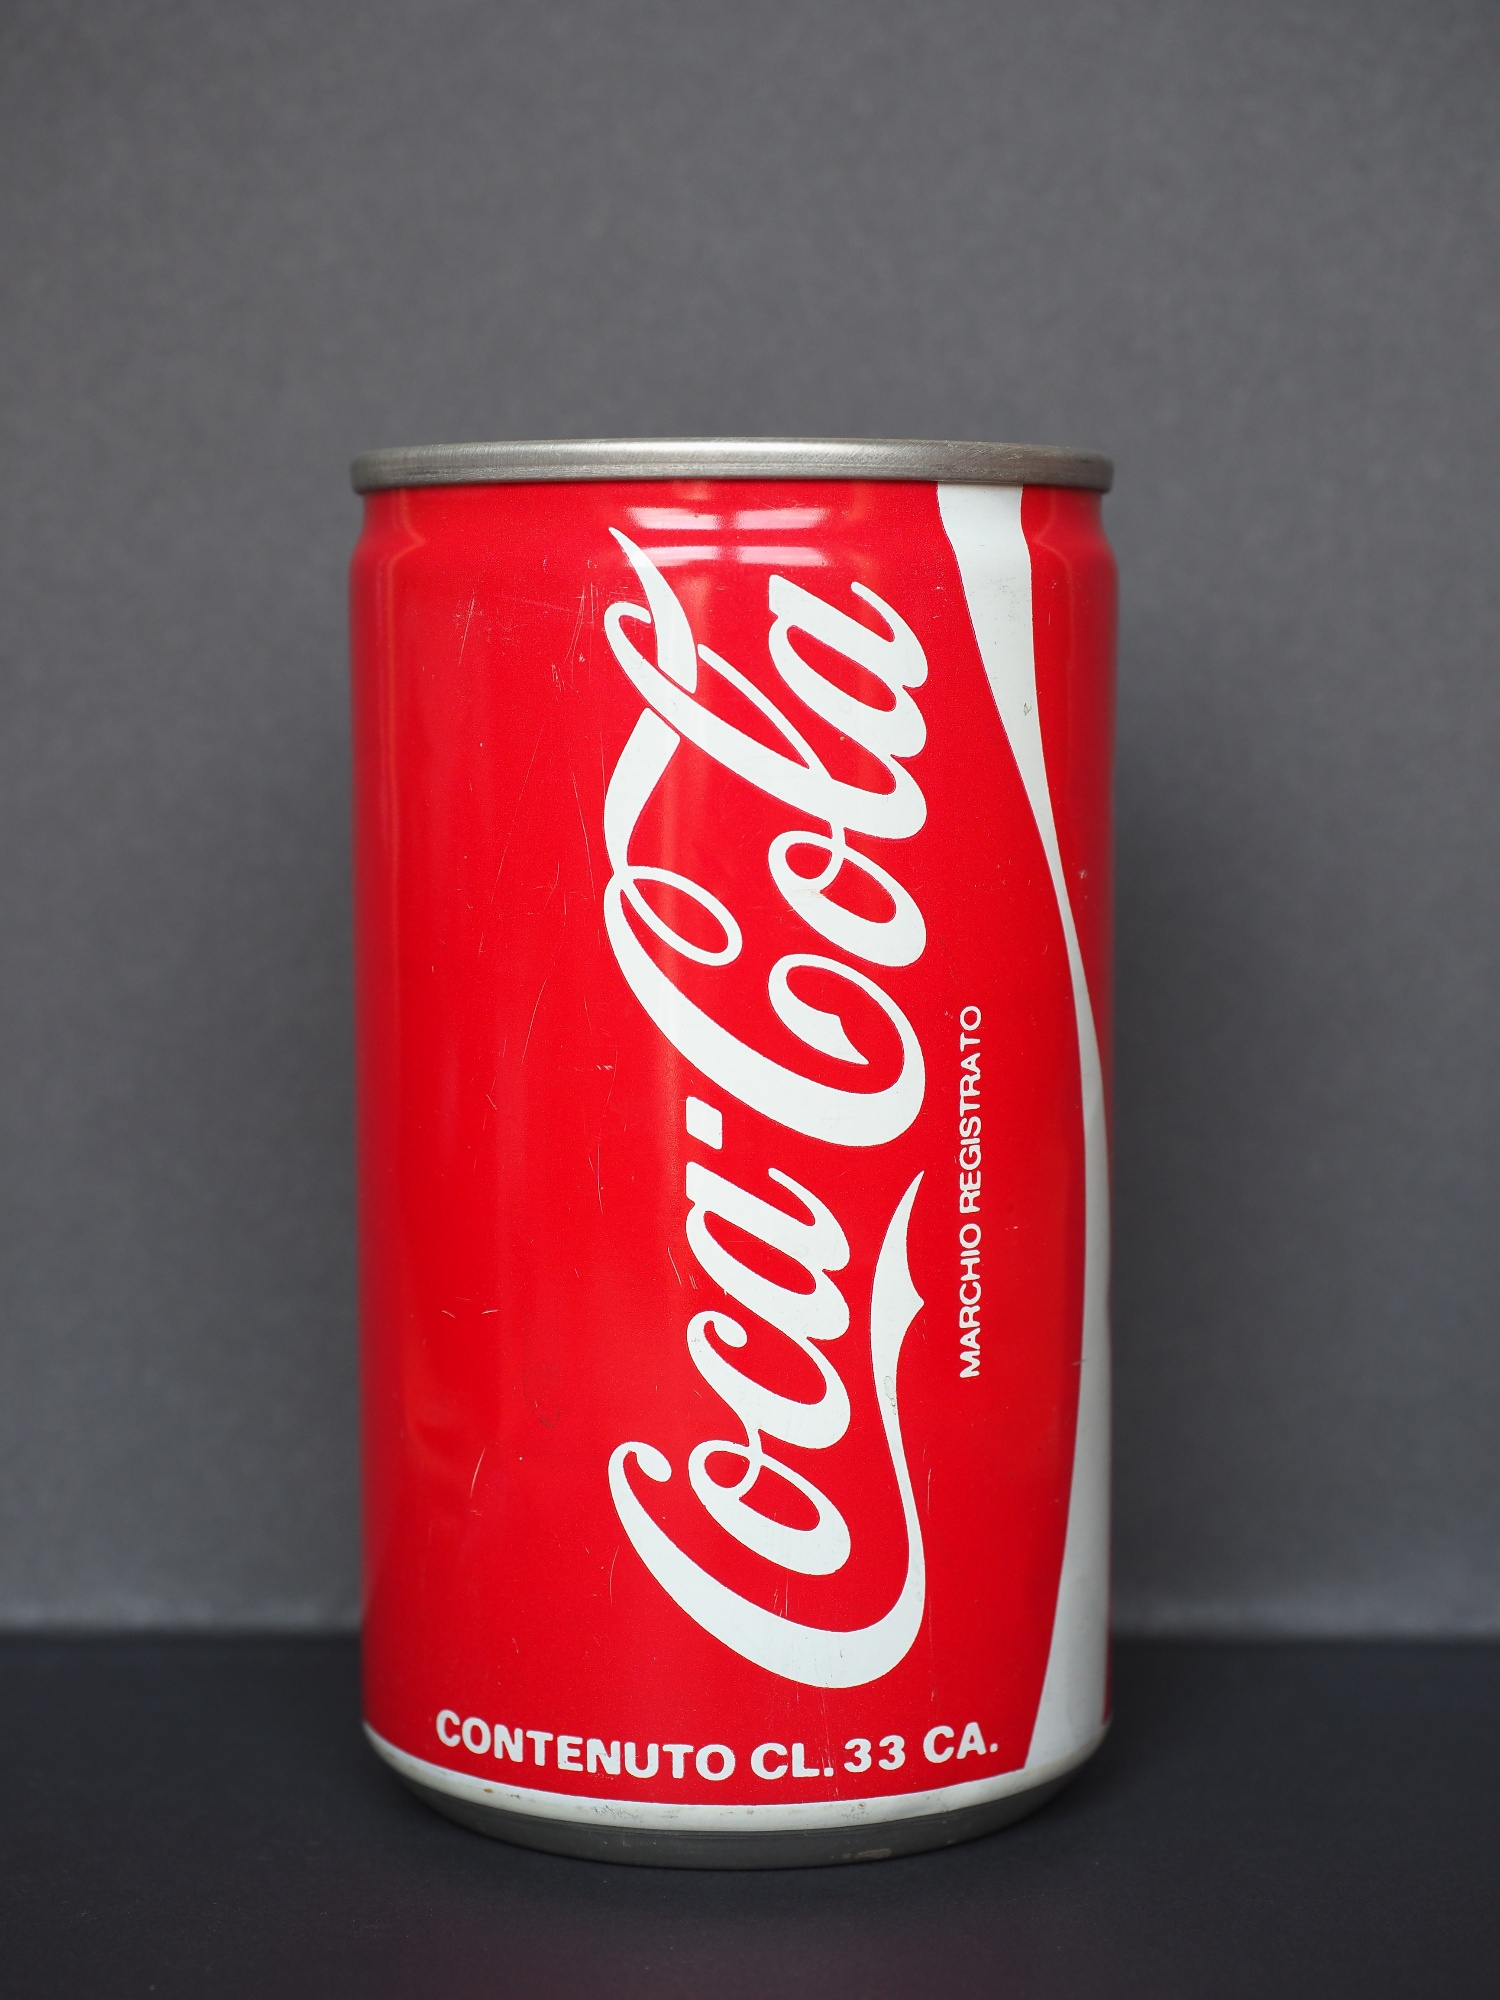Create a wildly imaginative scenario involving this can. In a distant future, this Coca Cola can is no ordinary beverage container. It is, in fact, a highly advanced piece of alien technology disguised to blend in with human society. One day, young Clara found this peculiar can while exploring her grandfather's attic. Curious, she took it, unknowingly activating its secret function. The can began to glow and transform, revealing a holographic map of the galaxy. The map pinpointed various locations, indicating hidden relics of an ancient alien civilization. Clara, now the chosen protector, embarks on an interstellar adventure, using the can to unlock portals, decode alien languages, and discover the secrets of the cosmos. The simple Coca Cola can becomes her guide, leading her through thrilling space escapades and uncovering mysteries far beyond Earth's understanding. 